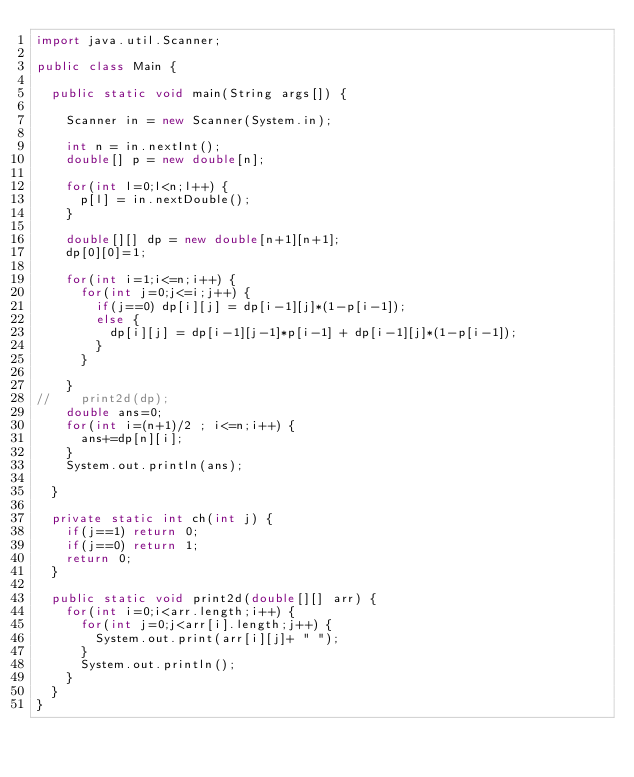<code> <loc_0><loc_0><loc_500><loc_500><_Java_>import java.util.Scanner;

public class Main {
	
	public static void main(String args[]) {
		
		Scanner in = new Scanner(System.in);

		int n = in.nextInt();
		double[] p = new double[n];
		
		for(int l=0;l<n;l++) {
			p[l] = in.nextDouble();
		}
		
		double[][] dp = new double[n+1][n+1];
		dp[0][0]=1;
		
		for(int i=1;i<=n;i++) {
			for(int j=0;j<=i;j++) {
				if(j==0) dp[i][j] = dp[i-1][j]*(1-p[i-1]);
				else {
					dp[i][j] = dp[i-1][j-1]*p[i-1] + dp[i-1][j]*(1-p[i-1]);
				}
			}
				
		}
//		print2d(dp);
		double ans=0;
		for(int i=(n+1)/2 ; i<=n;i++) {
			ans+=dp[n][i];
		}
		System.out.println(ans);

	}
		
	private static int ch(int j) {
		if(j==1) return 0;
		if(j==0) return 1;
		return 0;
	}

	public static void print2d(double[][] arr) {
		for(int i=0;i<arr.length;i++) {
			for(int j=0;j<arr[i].length;j++) {
				System.out.print(arr[i][j]+ " ");
			}
			System.out.println();
		}
	}
}</code> 